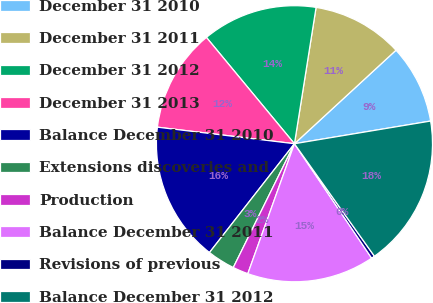Convert chart. <chart><loc_0><loc_0><loc_500><loc_500><pie_chart><fcel>December 31 2010<fcel>December 31 2011<fcel>December 31 2012<fcel>December 31 2013<fcel>Balance December 31 2010<fcel>Extensions discoveries and<fcel>Production<fcel>Balance December 31 2011<fcel>Revisions of previous<fcel>Balance December 31 2012<nl><fcel>9.22%<fcel>10.65%<fcel>13.51%<fcel>12.08%<fcel>16.36%<fcel>3.25%<fcel>1.82%<fcel>14.93%<fcel>0.39%<fcel>17.79%<nl></chart> 